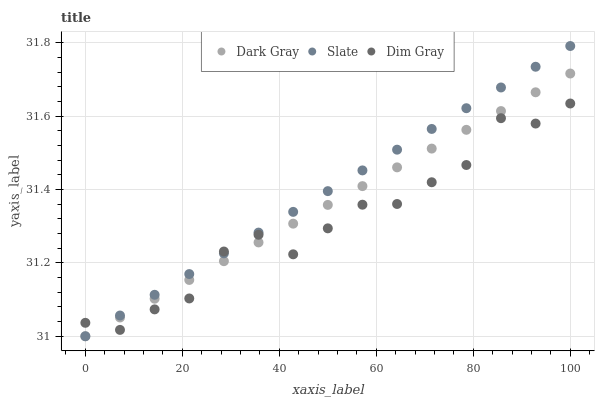Does Dim Gray have the minimum area under the curve?
Answer yes or no. Yes. Does Slate have the maximum area under the curve?
Answer yes or no. Yes. Does Slate have the minimum area under the curve?
Answer yes or no. No. Does Dim Gray have the maximum area under the curve?
Answer yes or no. No. Is Slate the smoothest?
Answer yes or no. Yes. Is Dim Gray the roughest?
Answer yes or no. Yes. Is Dim Gray the smoothest?
Answer yes or no. No. Is Slate the roughest?
Answer yes or no. No. Does Dark Gray have the lowest value?
Answer yes or no. Yes. Does Dim Gray have the lowest value?
Answer yes or no. No. Does Slate have the highest value?
Answer yes or no. Yes. Does Dim Gray have the highest value?
Answer yes or no. No. Does Dark Gray intersect Slate?
Answer yes or no. Yes. Is Dark Gray less than Slate?
Answer yes or no. No. Is Dark Gray greater than Slate?
Answer yes or no. No. 